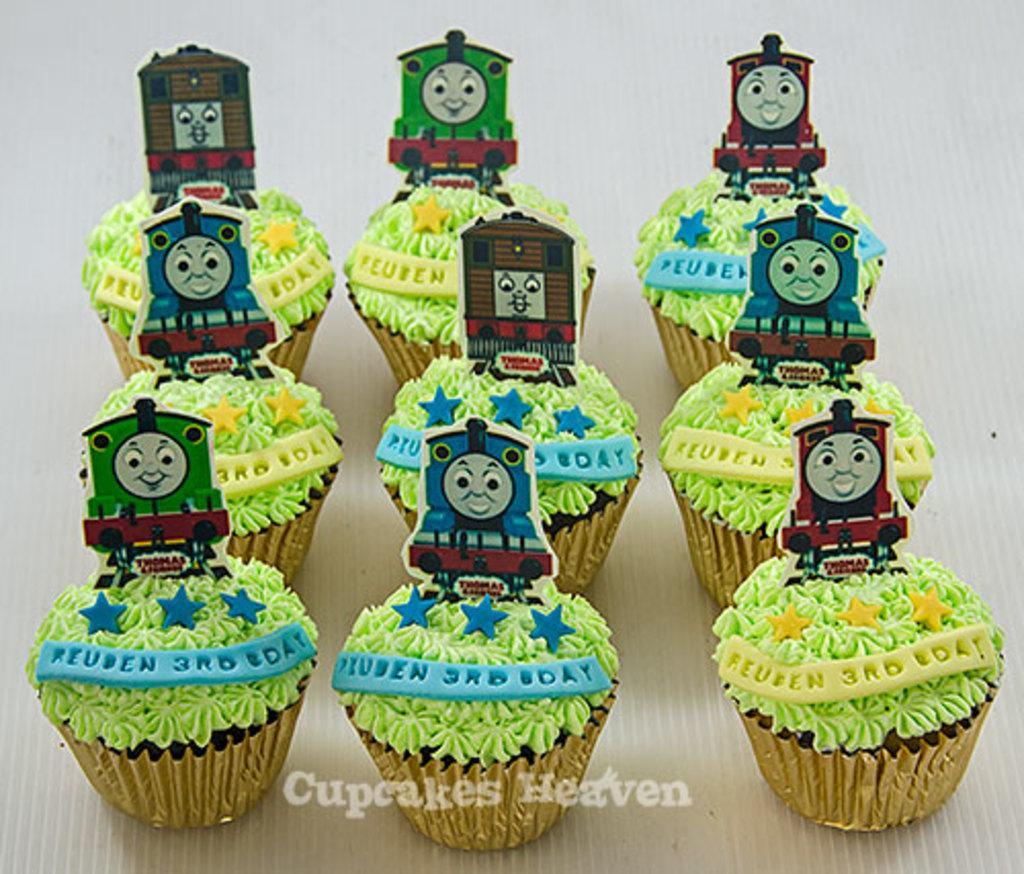Describe this image in one or two sentences. In the foreground of this image, there are cupcakes and few posters on it which are placed on the white surface. 